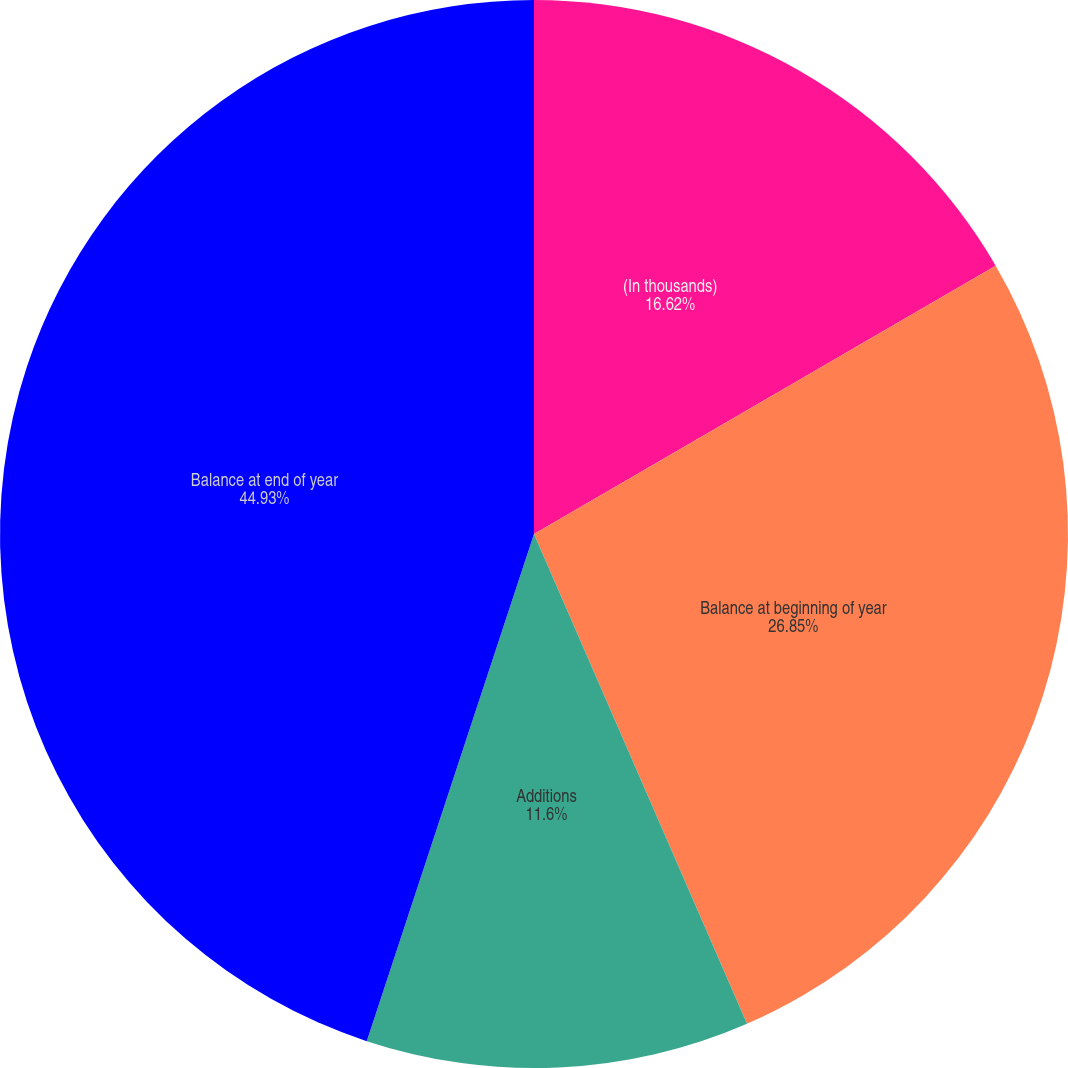<chart> <loc_0><loc_0><loc_500><loc_500><pie_chart><fcel>(In thousands)<fcel>Balance at beginning of year<fcel>Additions<fcel>Balance at end of year<nl><fcel>16.62%<fcel>26.85%<fcel>11.6%<fcel>44.93%<nl></chart> 